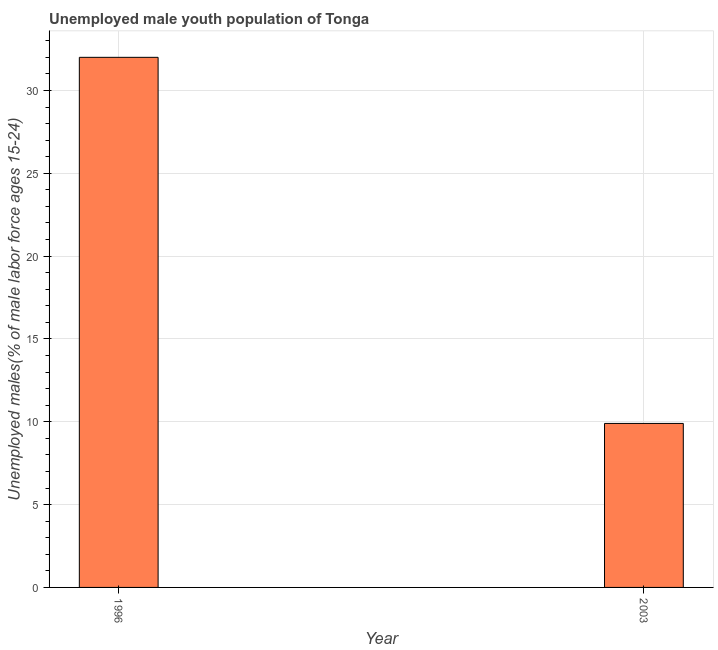Does the graph contain grids?
Your answer should be compact. Yes. What is the title of the graph?
Provide a succinct answer. Unemployed male youth population of Tonga. What is the label or title of the Y-axis?
Make the answer very short. Unemployed males(% of male labor force ages 15-24). Across all years, what is the minimum unemployed male youth?
Your response must be concise. 9.9. In which year was the unemployed male youth minimum?
Provide a short and direct response. 2003. What is the sum of the unemployed male youth?
Keep it short and to the point. 41.9. What is the difference between the unemployed male youth in 1996 and 2003?
Make the answer very short. 22.1. What is the average unemployed male youth per year?
Offer a very short reply. 20.95. What is the median unemployed male youth?
Ensure brevity in your answer.  20.95. In how many years, is the unemployed male youth greater than 12 %?
Offer a terse response. 1. Do a majority of the years between 2003 and 1996 (inclusive) have unemployed male youth greater than 3 %?
Your answer should be very brief. No. What is the ratio of the unemployed male youth in 1996 to that in 2003?
Offer a very short reply. 3.23. In how many years, is the unemployed male youth greater than the average unemployed male youth taken over all years?
Offer a terse response. 1. How many bars are there?
Your answer should be very brief. 2. How many years are there in the graph?
Ensure brevity in your answer.  2. What is the difference between two consecutive major ticks on the Y-axis?
Provide a succinct answer. 5. Are the values on the major ticks of Y-axis written in scientific E-notation?
Your answer should be compact. No. What is the Unemployed males(% of male labor force ages 15-24) in 1996?
Your response must be concise. 32. What is the Unemployed males(% of male labor force ages 15-24) of 2003?
Your answer should be compact. 9.9. What is the difference between the Unemployed males(% of male labor force ages 15-24) in 1996 and 2003?
Keep it short and to the point. 22.1. What is the ratio of the Unemployed males(% of male labor force ages 15-24) in 1996 to that in 2003?
Your answer should be very brief. 3.23. 